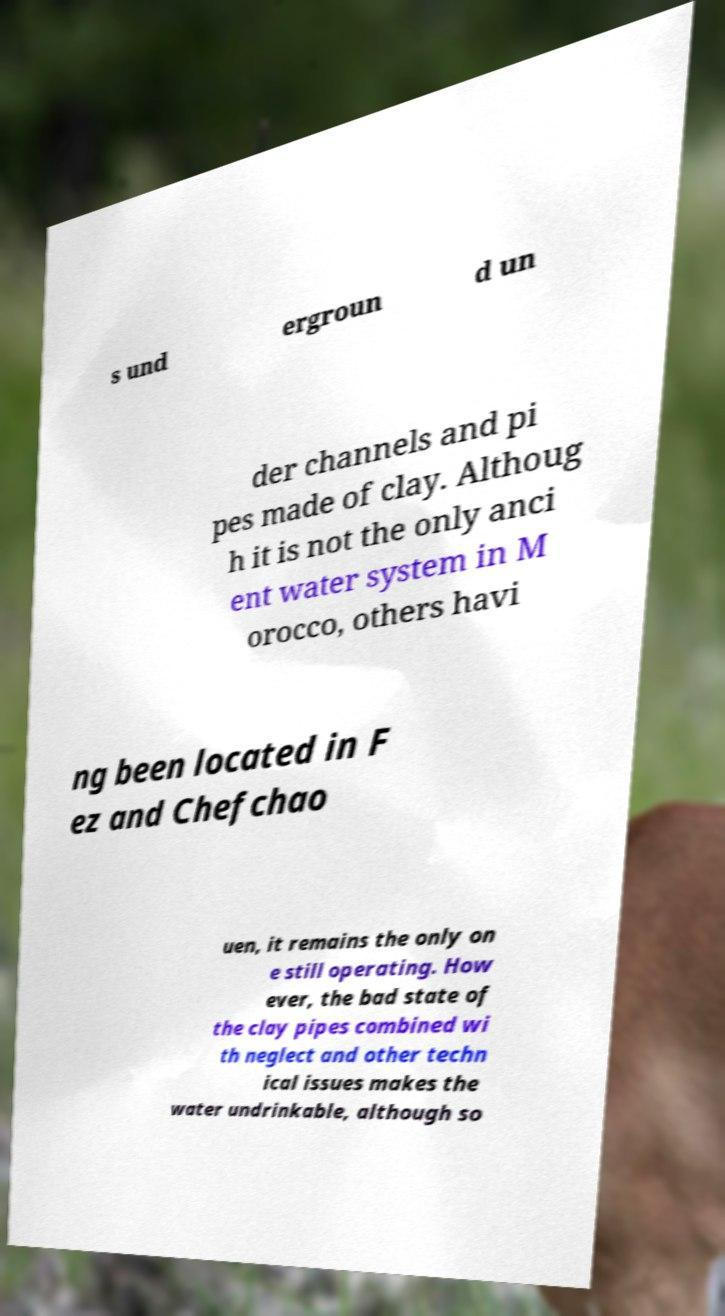Please read and relay the text visible in this image. What does it say? s und ergroun d un der channels and pi pes made of clay. Althoug h it is not the only anci ent water system in M orocco, others havi ng been located in F ez and Chefchao uen, it remains the only on e still operating. How ever, the bad state of the clay pipes combined wi th neglect and other techn ical issues makes the water undrinkable, although so 